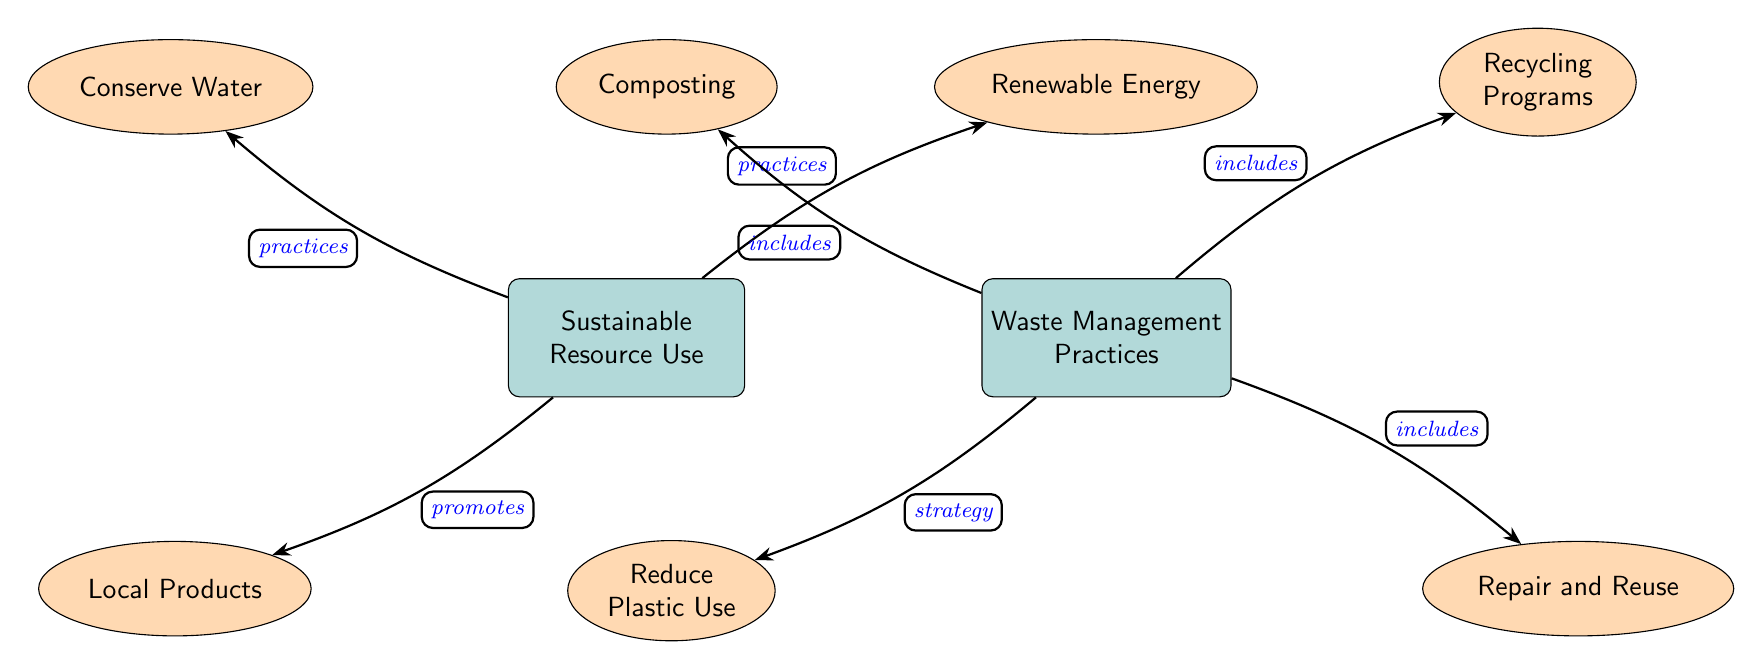What are the main categories in the diagram? The diagram has two main categories, which are 'Sustainable Resource Use' and 'Waste Management Practices'. These categories are represented by main nodes in the diagram.
Answer: Sustainable Resource Use, Waste Management Practices How many sub nodes are associated with Sustainable Resource Use? There are three sub nodes connected to 'Sustainable Resource Use': 'Conserve Water', 'Renewable Energy', and 'Local Products'. Each of these sub nodes is depicted as an ellipse connected to the main node.
Answer: 3 What practice promotes the use of local products? The main node 'Sustainable Resource Use' promotes the sub node 'Local Products', meaning there's a direct connection indicating that using local products is a practice to encourage sustainable resource use.
Answer: Local Products Which waste management practice includes composting? The node 'Waste Management Practices' includes the sub node 'Composting', which indicates that composting is one of the practices listed under waste management in the diagram.
Answer: Composting What type of relationship exists between Renewable Energy and Sustainable Resource Use? The relationship between 'Renewable Energy' and 'Sustainable Resource Use' is described as 'practices', indicating that renewable energy is a practice that falls under the broader category of sustainable resource use in the diagram.
Answer: practices Which waste management practices focus on reducing materials? The waste management category encompasses 'Reduce Plastic Use', which directly highlights an approach aimed at minimizing waste generation associated with plastics. This indicates a focus on reducing materials.
Answer: Reduce Plastic Use Which nodes have connections that indicate inclusion? The nodes 'Composting', 'Recycling Programs', and 'Repair and Reuse' are connected to 'Waste Management Practices' through the relationship labeled as 'includes', showcasing practices that are part of waste management.
Answer: Composting, Recycling Programs, Repair and Reuse What strategy is associated with reducing waste? The strategy for reducing waste indicated in the diagram is embodied in the node 'Reduce Plastic Use', which highlights a tactical approach to managing waste effectively by limiting plastic usage.
Answer: Reduce Plastic Use 